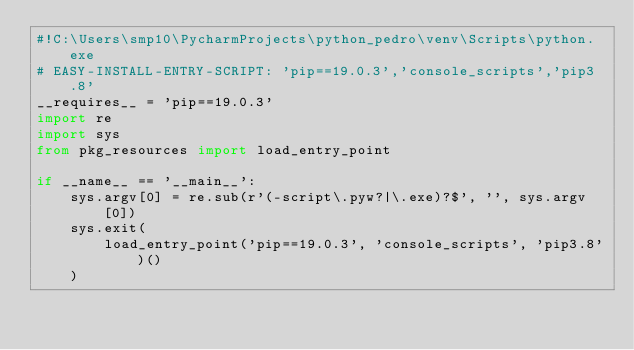<code> <loc_0><loc_0><loc_500><loc_500><_Python_>#!C:\Users\smp10\PycharmProjects\python_pedro\venv\Scripts\python.exe
# EASY-INSTALL-ENTRY-SCRIPT: 'pip==19.0.3','console_scripts','pip3.8'
__requires__ = 'pip==19.0.3'
import re
import sys
from pkg_resources import load_entry_point

if __name__ == '__main__':
    sys.argv[0] = re.sub(r'(-script\.pyw?|\.exe)?$', '', sys.argv[0])
    sys.exit(
        load_entry_point('pip==19.0.3', 'console_scripts', 'pip3.8')()
    )
</code> 